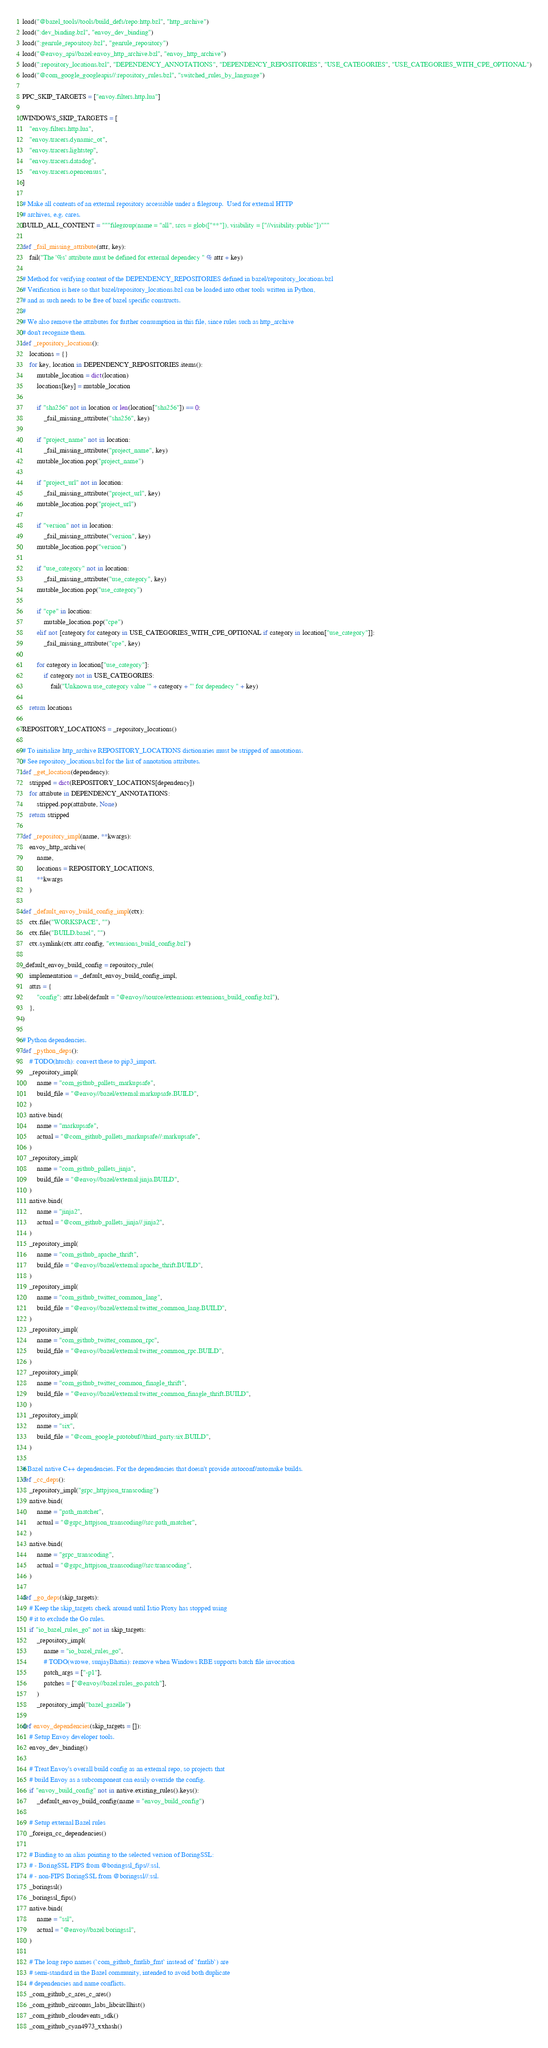<code> <loc_0><loc_0><loc_500><loc_500><_Python_>load("@bazel_tools//tools/build_defs/repo:http.bzl", "http_archive")
load(":dev_binding.bzl", "envoy_dev_binding")
load(":genrule_repository.bzl", "genrule_repository")
load("@envoy_api//bazel:envoy_http_archive.bzl", "envoy_http_archive")
load(":repository_locations.bzl", "DEPENDENCY_ANNOTATIONS", "DEPENDENCY_REPOSITORIES", "USE_CATEGORIES", "USE_CATEGORIES_WITH_CPE_OPTIONAL")
load("@com_google_googleapis//:repository_rules.bzl", "switched_rules_by_language")

PPC_SKIP_TARGETS = ["envoy.filters.http.lua"]

WINDOWS_SKIP_TARGETS = [
    "envoy.filters.http.lua",
    "envoy.tracers.dynamic_ot",
    "envoy.tracers.lightstep",
    "envoy.tracers.datadog",
    "envoy.tracers.opencensus",
]

# Make all contents of an external repository accessible under a filegroup.  Used for external HTTP
# archives, e.g. cares.
BUILD_ALL_CONTENT = """filegroup(name = "all", srcs = glob(["**"]), visibility = ["//visibility:public"])"""

def _fail_missing_attribute(attr, key):
    fail("The '%s' attribute must be defined for external dependecy " % attr + key)

# Method for verifying content of the DEPENDENCY_REPOSITORIES defined in bazel/repository_locations.bzl
# Verification is here so that bazel/repository_locations.bzl can be loaded into other tools written in Python,
# and as such needs to be free of bazel specific constructs.
#
# We also remove the attributes for further consumption in this file, since rules such as http_archive
# don't recognize them.
def _repository_locations():
    locations = {}
    for key, location in DEPENDENCY_REPOSITORIES.items():
        mutable_location = dict(location)
        locations[key] = mutable_location

        if "sha256" not in location or len(location["sha256"]) == 0:
            _fail_missing_attribute("sha256", key)

        if "project_name" not in location:
            _fail_missing_attribute("project_name", key)
        mutable_location.pop("project_name")

        if "project_url" not in location:
            _fail_missing_attribute("project_url", key)
        mutable_location.pop("project_url")

        if "version" not in location:
            _fail_missing_attribute("version", key)
        mutable_location.pop("version")

        if "use_category" not in location:
            _fail_missing_attribute("use_category", key)
        mutable_location.pop("use_category")

        if "cpe" in location:
            mutable_location.pop("cpe")
        elif not [category for category in USE_CATEGORIES_WITH_CPE_OPTIONAL if category in location["use_category"]]:
            _fail_missing_attribute("cpe", key)

        for category in location["use_category"]:
            if category not in USE_CATEGORIES:
                fail("Unknown use_category value '" + category + "' for dependecy " + key)

    return locations

REPOSITORY_LOCATIONS = _repository_locations()

# To initialize http_archive REPOSITORY_LOCATIONS dictionaries must be stripped of annotations.
# See repository_locations.bzl for the list of annotation attributes.
def _get_location(dependency):
    stripped = dict(REPOSITORY_LOCATIONS[dependency])
    for attribute in DEPENDENCY_ANNOTATIONS:
        stripped.pop(attribute, None)
    return stripped

def _repository_impl(name, **kwargs):
    envoy_http_archive(
        name,
        locations = REPOSITORY_LOCATIONS,
        **kwargs
    )

def _default_envoy_build_config_impl(ctx):
    ctx.file("WORKSPACE", "")
    ctx.file("BUILD.bazel", "")
    ctx.symlink(ctx.attr.config, "extensions_build_config.bzl")

_default_envoy_build_config = repository_rule(
    implementation = _default_envoy_build_config_impl,
    attrs = {
        "config": attr.label(default = "@envoy//source/extensions:extensions_build_config.bzl"),
    },
)

# Python dependencies.
def _python_deps():
    # TODO(htuch): convert these to pip3_import.
    _repository_impl(
        name = "com_github_pallets_markupsafe",
        build_file = "@envoy//bazel/external:markupsafe.BUILD",
    )
    native.bind(
        name = "markupsafe",
        actual = "@com_github_pallets_markupsafe//:markupsafe",
    )
    _repository_impl(
        name = "com_github_pallets_jinja",
        build_file = "@envoy//bazel/external:jinja.BUILD",
    )
    native.bind(
        name = "jinja2",
        actual = "@com_github_pallets_jinja//:jinja2",
    )
    _repository_impl(
        name = "com_github_apache_thrift",
        build_file = "@envoy//bazel/external:apache_thrift.BUILD",
    )
    _repository_impl(
        name = "com_github_twitter_common_lang",
        build_file = "@envoy//bazel/external:twitter_common_lang.BUILD",
    )
    _repository_impl(
        name = "com_github_twitter_common_rpc",
        build_file = "@envoy//bazel/external:twitter_common_rpc.BUILD",
    )
    _repository_impl(
        name = "com_github_twitter_common_finagle_thrift",
        build_file = "@envoy//bazel/external:twitter_common_finagle_thrift.BUILD",
    )
    _repository_impl(
        name = "six",
        build_file = "@com_google_protobuf//third_party:six.BUILD",
    )

# Bazel native C++ dependencies. For the dependencies that doesn't provide autoconf/automake builds.
def _cc_deps():
    _repository_impl("grpc_httpjson_transcoding")
    native.bind(
        name = "path_matcher",
        actual = "@grpc_httpjson_transcoding//src:path_matcher",
    )
    native.bind(
        name = "grpc_transcoding",
        actual = "@grpc_httpjson_transcoding//src:transcoding",
    )

def _go_deps(skip_targets):
    # Keep the skip_targets check around until Istio Proxy has stopped using
    # it to exclude the Go rules.
    if "io_bazel_rules_go" not in skip_targets:
        _repository_impl(
            name = "io_bazel_rules_go",
            # TODO(wrowe, sunjayBhatia): remove when Windows RBE supports batch file invocation
            patch_args = ["-p1"],
            patches = ["@envoy//bazel:rules_go.patch"],
        )
        _repository_impl("bazel_gazelle")

def envoy_dependencies(skip_targets = []):
    # Setup Envoy developer tools.
    envoy_dev_binding()

    # Treat Envoy's overall build config as an external repo, so projects that
    # build Envoy as a subcomponent can easily override the config.
    if "envoy_build_config" not in native.existing_rules().keys():
        _default_envoy_build_config(name = "envoy_build_config")

    # Setup external Bazel rules
    _foreign_cc_dependencies()

    # Binding to an alias pointing to the selected version of BoringSSL:
    # - BoringSSL FIPS from @boringssl_fips//:ssl,
    # - non-FIPS BoringSSL from @boringssl//:ssl.
    _boringssl()
    _boringssl_fips()
    native.bind(
        name = "ssl",
        actual = "@envoy//bazel:boringssl",
    )

    # The long repo names (`com_github_fmtlib_fmt` instead of `fmtlib`) are
    # semi-standard in the Bazel community, intended to avoid both duplicate
    # dependencies and name conflicts.
    _com_github_c_ares_c_ares()
    _com_github_circonus_labs_libcircllhist()
    _com_github_cloudevents_sdk()
    _com_github_cyan4973_xxhash()</code> 